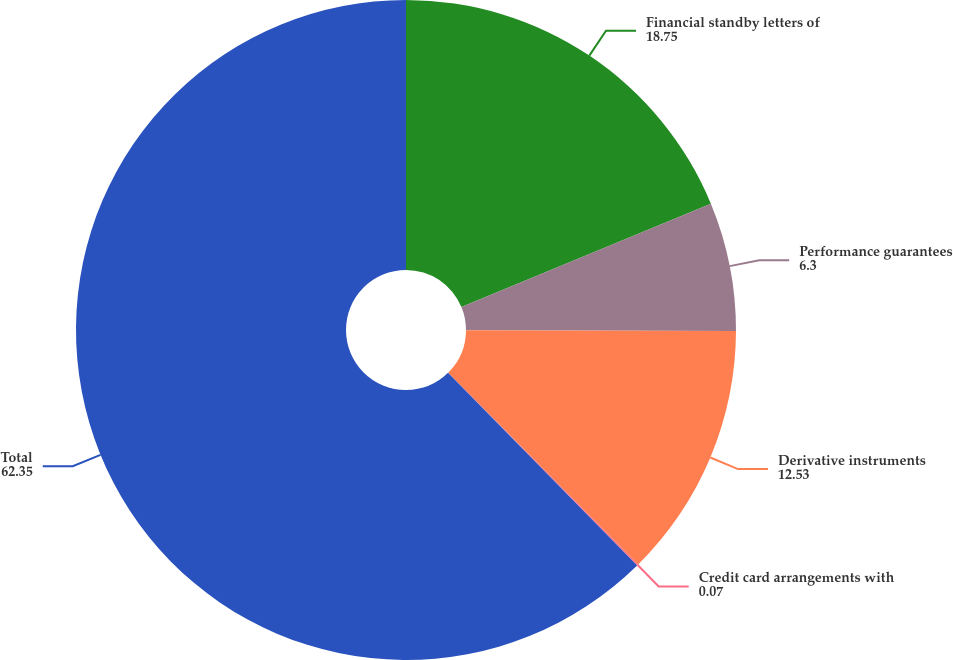Convert chart to OTSL. <chart><loc_0><loc_0><loc_500><loc_500><pie_chart><fcel>Financial standby letters of<fcel>Performance guarantees<fcel>Derivative instruments<fcel>Credit card arrangements with<fcel>Total<nl><fcel>18.75%<fcel>6.3%<fcel>12.53%<fcel>0.07%<fcel>62.35%<nl></chart> 